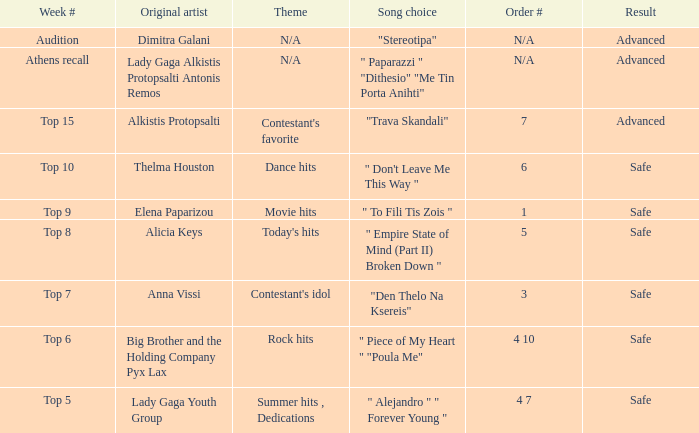Which artists have order number 6? Thelma Houston. 